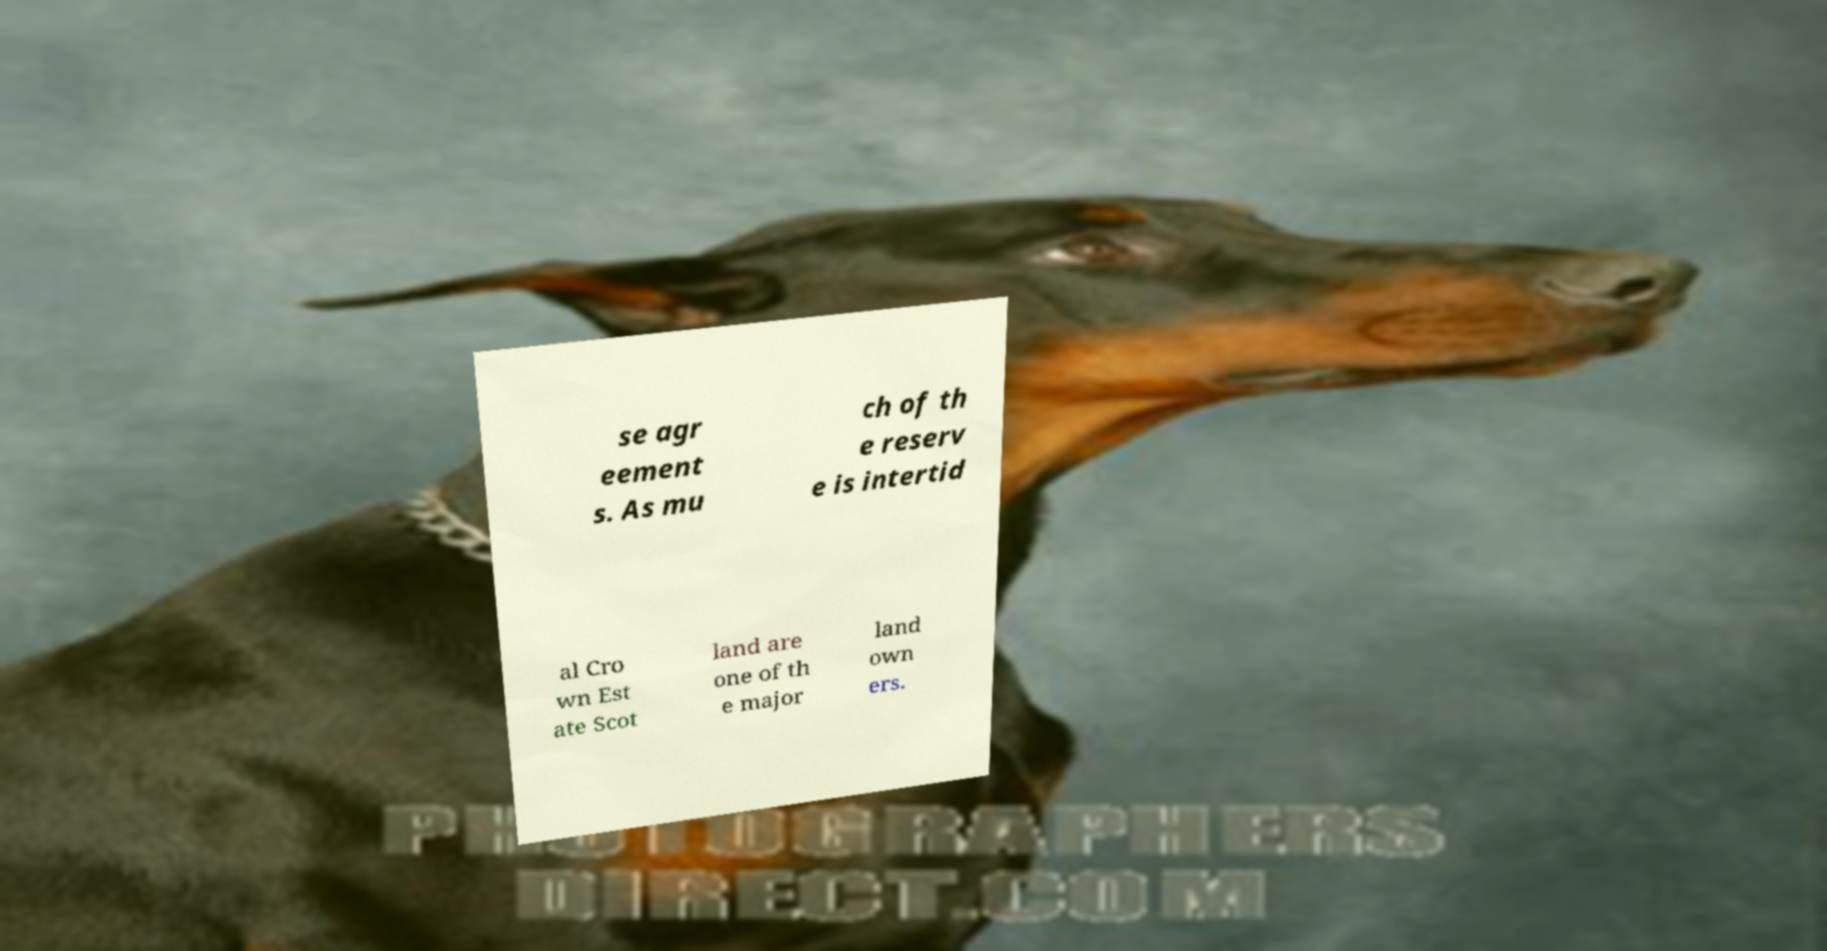There's text embedded in this image that I need extracted. Can you transcribe it verbatim? se agr eement s. As mu ch of th e reserv e is intertid al Cro wn Est ate Scot land are one of th e major land own ers. 